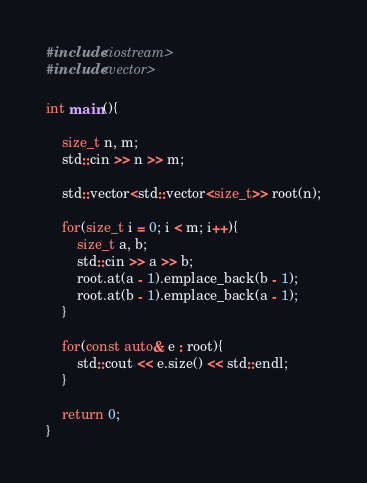Convert code to text. <code><loc_0><loc_0><loc_500><loc_500><_C++_>#include<iostream>
#include<vector>

int main(){
    
    size_t n, m;
    std::cin >> n >> m;

    std::vector<std::vector<size_t>> root(n);

    for(size_t i = 0; i < m; i++){
        size_t a, b;
        std::cin >> a >> b;
        root.at(a - 1).emplace_back(b - 1);
        root.at(b - 1).emplace_back(a - 1);
    }

    for(const auto& e : root){
        std::cout << e.size() << std::endl;
    }
    
    return 0;
}
</code> 